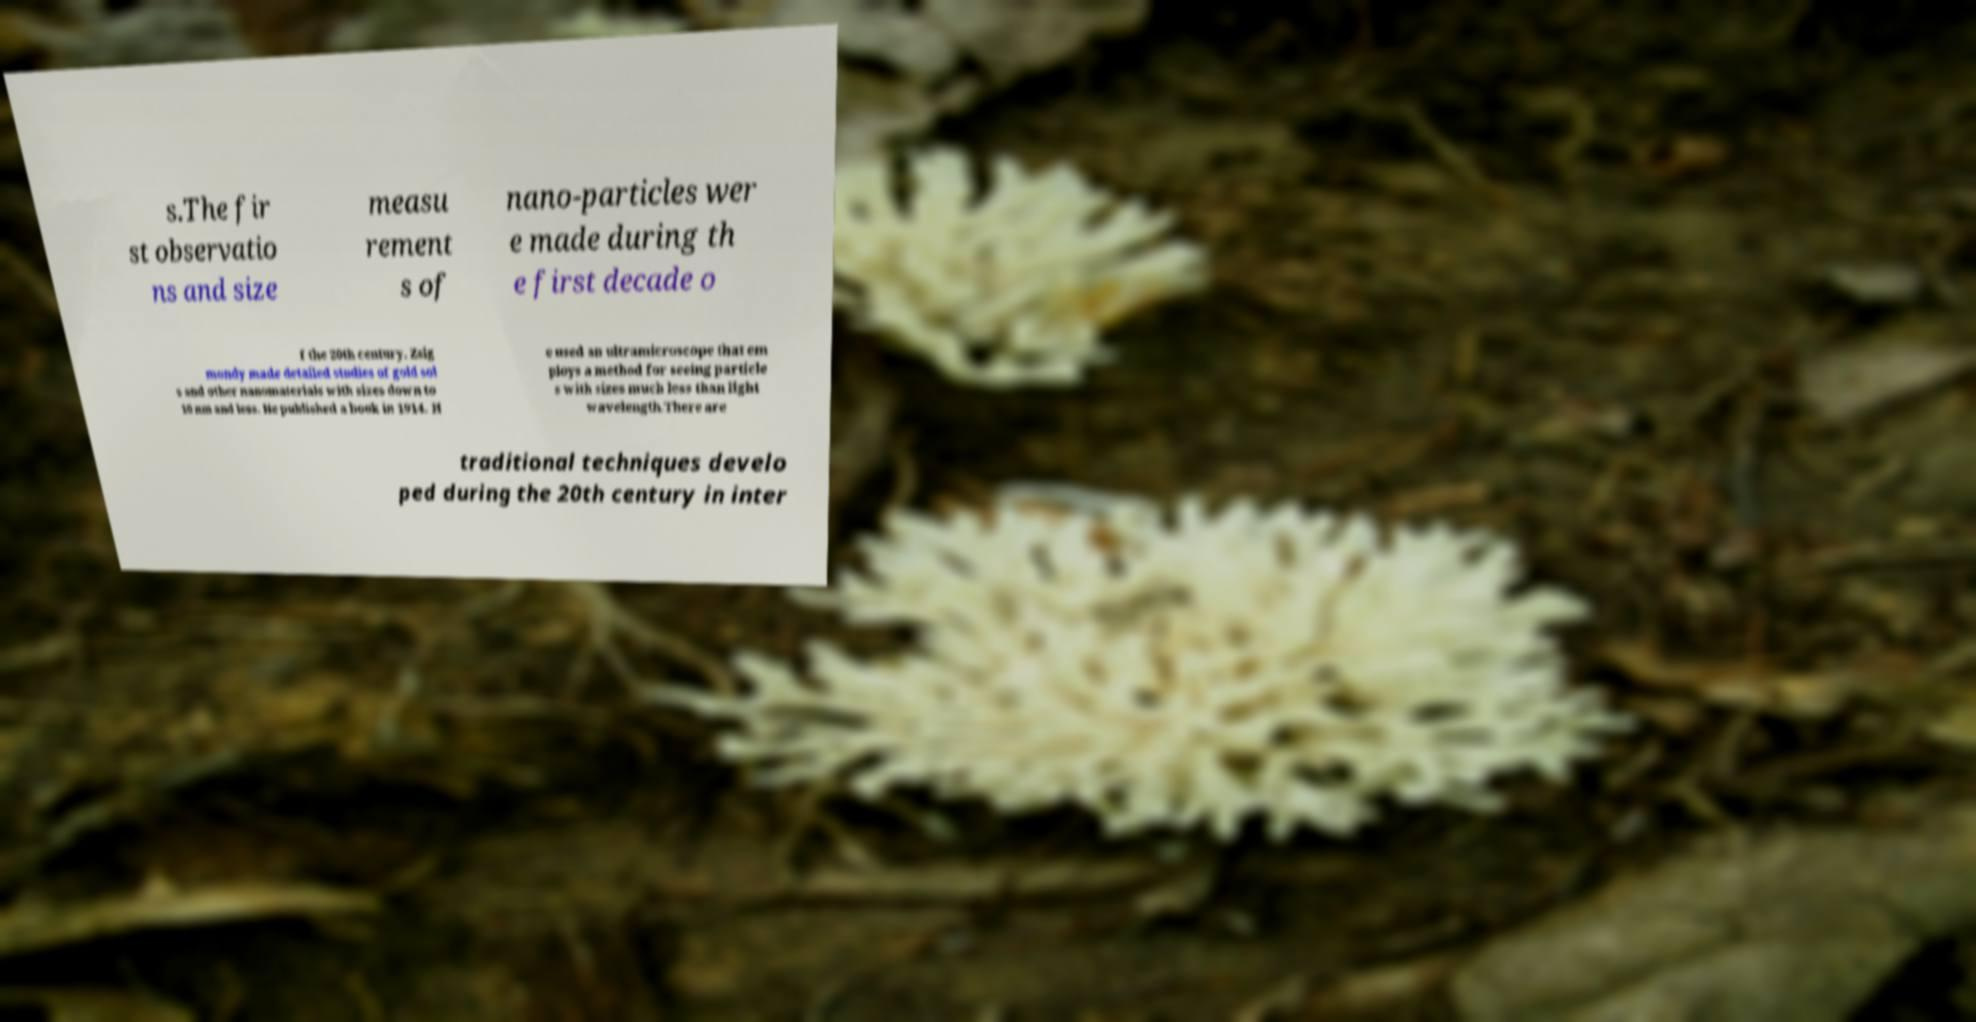Can you accurately transcribe the text from the provided image for me? s.The fir st observatio ns and size measu rement s of nano-particles wer e made during th e first decade o f the 20th century. Zsig mondy made detailed studies of gold sol s and other nanomaterials with sizes down to 10 nm and less. He published a book in 1914. H e used an ultramicroscope that em ploys a method for seeing particle s with sizes much less than light wavelength.There are traditional techniques develo ped during the 20th century in inter 